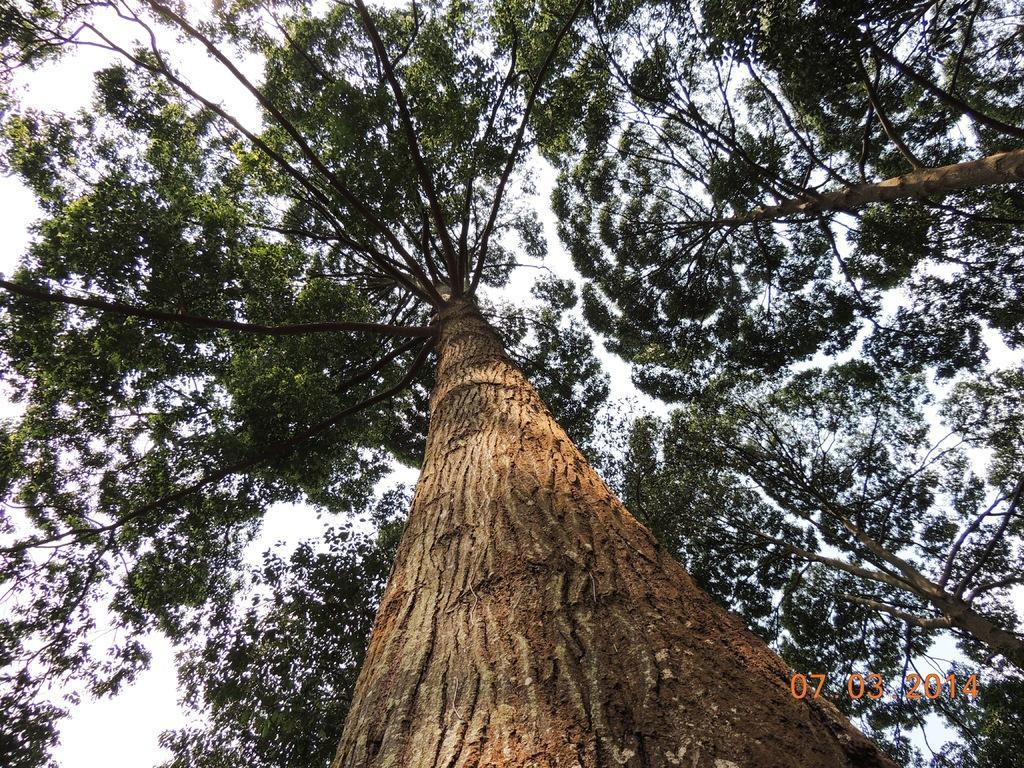Describe this image in one or two sentences. In this image there is a tree in middle of this image and there are some other trees at right side of this image and as we can see there is a sky in the background. 